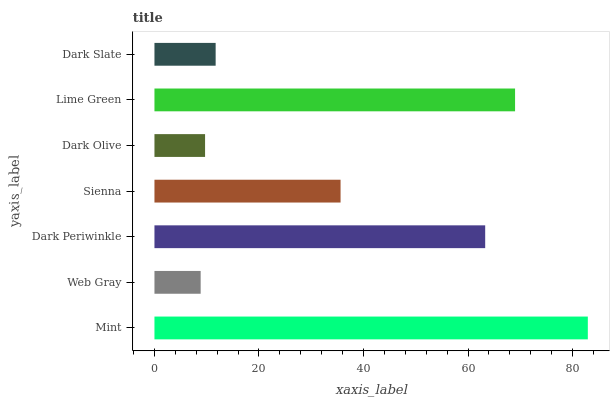Is Web Gray the minimum?
Answer yes or no. Yes. Is Mint the maximum?
Answer yes or no. Yes. Is Dark Periwinkle the minimum?
Answer yes or no. No. Is Dark Periwinkle the maximum?
Answer yes or no. No. Is Dark Periwinkle greater than Web Gray?
Answer yes or no. Yes. Is Web Gray less than Dark Periwinkle?
Answer yes or no. Yes. Is Web Gray greater than Dark Periwinkle?
Answer yes or no. No. Is Dark Periwinkle less than Web Gray?
Answer yes or no. No. Is Sienna the high median?
Answer yes or no. Yes. Is Sienna the low median?
Answer yes or no. Yes. Is Dark Slate the high median?
Answer yes or no. No. Is Web Gray the low median?
Answer yes or no. No. 